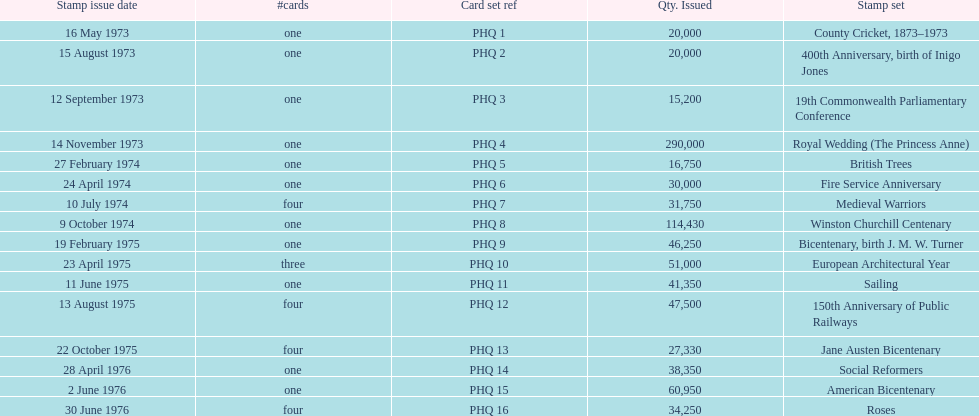Which stamp set had only three cards in the set? European Architectural Year. 